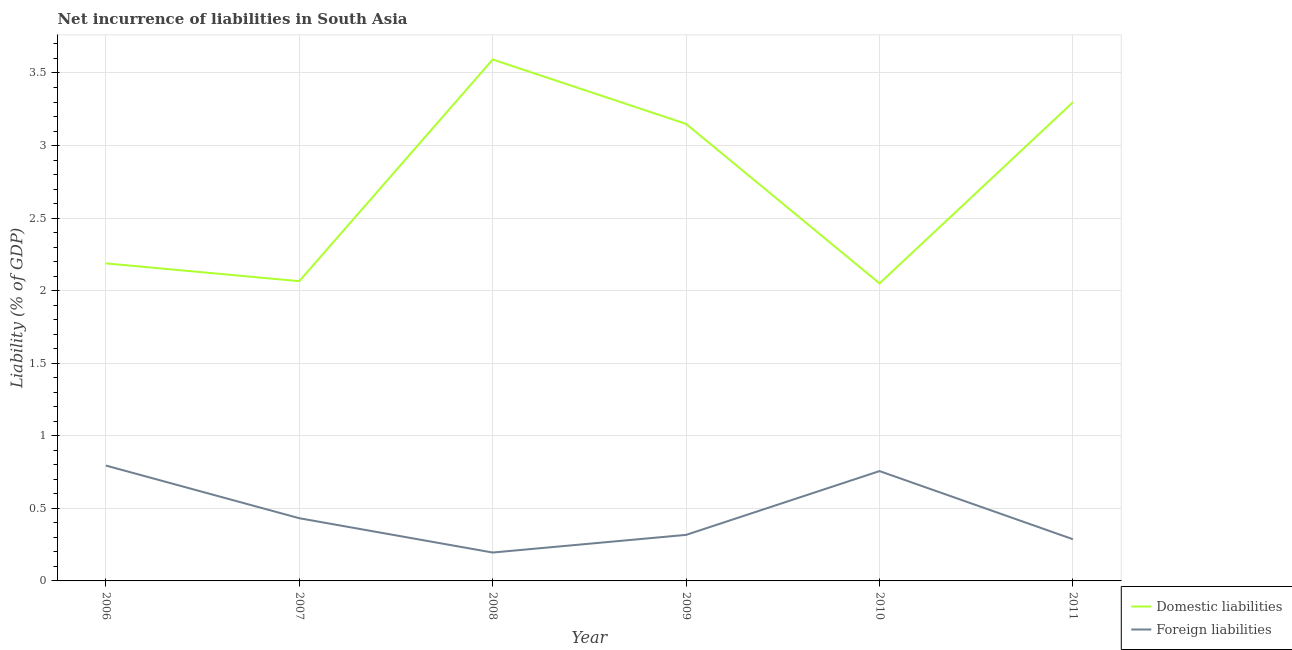How many different coloured lines are there?
Provide a short and direct response. 2. Is the number of lines equal to the number of legend labels?
Your response must be concise. Yes. What is the incurrence of foreign liabilities in 2011?
Provide a succinct answer. 0.29. Across all years, what is the maximum incurrence of domestic liabilities?
Make the answer very short. 3.59. Across all years, what is the minimum incurrence of foreign liabilities?
Your answer should be very brief. 0.2. What is the total incurrence of foreign liabilities in the graph?
Provide a succinct answer. 2.78. What is the difference between the incurrence of domestic liabilities in 2008 and that in 2010?
Provide a short and direct response. 1.54. What is the difference between the incurrence of domestic liabilities in 2011 and the incurrence of foreign liabilities in 2006?
Offer a very short reply. 2.5. What is the average incurrence of foreign liabilities per year?
Offer a terse response. 0.46. In the year 2006, what is the difference between the incurrence of foreign liabilities and incurrence of domestic liabilities?
Your answer should be compact. -1.39. In how many years, is the incurrence of domestic liabilities greater than 2.9 %?
Your answer should be very brief. 3. What is the ratio of the incurrence of foreign liabilities in 2007 to that in 2008?
Your answer should be compact. 2.21. Is the incurrence of foreign liabilities in 2010 less than that in 2011?
Give a very brief answer. No. Is the difference between the incurrence of foreign liabilities in 2010 and 2011 greater than the difference between the incurrence of domestic liabilities in 2010 and 2011?
Keep it short and to the point. Yes. What is the difference between the highest and the second highest incurrence of domestic liabilities?
Your response must be concise. 0.29. What is the difference between the highest and the lowest incurrence of foreign liabilities?
Give a very brief answer. 0.6. In how many years, is the incurrence of domestic liabilities greater than the average incurrence of domestic liabilities taken over all years?
Your answer should be very brief. 3. Is the incurrence of domestic liabilities strictly greater than the incurrence of foreign liabilities over the years?
Make the answer very short. Yes. Is the incurrence of foreign liabilities strictly less than the incurrence of domestic liabilities over the years?
Offer a very short reply. Yes. How many lines are there?
Give a very brief answer. 2. What is the difference between two consecutive major ticks on the Y-axis?
Your answer should be very brief. 0.5. Does the graph contain grids?
Your answer should be compact. Yes. Where does the legend appear in the graph?
Provide a short and direct response. Bottom right. How are the legend labels stacked?
Ensure brevity in your answer.  Vertical. What is the title of the graph?
Provide a short and direct response. Net incurrence of liabilities in South Asia. What is the label or title of the X-axis?
Offer a very short reply. Year. What is the label or title of the Y-axis?
Keep it short and to the point. Liability (% of GDP). What is the Liability (% of GDP) of Domestic liabilities in 2006?
Keep it short and to the point. 2.19. What is the Liability (% of GDP) in Foreign liabilities in 2006?
Provide a short and direct response. 0.8. What is the Liability (% of GDP) in Domestic liabilities in 2007?
Provide a short and direct response. 2.07. What is the Liability (% of GDP) in Foreign liabilities in 2007?
Your response must be concise. 0.43. What is the Liability (% of GDP) in Domestic liabilities in 2008?
Keep it short and to the point. 3.59. What is the Liability (% of GDP) of Foreign liabilities in 2008?
Offer a terse response. 0.2. What is the Liability (% of GDP) of Domestic liabilities in 2009?
Make the answer very short. 3.15. What is the Liability (% of GDP) of Foreign liabilities in 2009?
Offer a very short reply. 0.32. What is the Liability (% of GDP) in Domestic liabilities in 2010?
Ensure brevity in your answer.  2.05. What is the Liability (% of GDP) in Foreign liabilities in 2010?
Your answer should be very brief. 0.76. What is the Liability (% of GDP) in Domestic liabilities in 2011?
Offer a terse response. 3.3. What is the Liability (% of GDP) in Foreign liabilities in 2011?
Keep it short and to the point. 0.29. Across all years, what is the maximum Liability (% of GDP) in Domestic liabilities?
Offer a terse response. 3.59. Across all years, what is the maximum Liability (% of GDP) in Foreign liabilities?
Keep it short and to the point. 0.8. Across all years, what is the minimum Liability (% of GDP) of Domestic liabilities?
Offer a very short reply. 2.05. Across all years, what is the minimum Liability (% of GDP) in Foreign liabilities?
Your answer should be very brief. 0.2. What is the total Liability (% of GDP) of Domestic liabilities in the graph?
Provide a short and direct response. 16.34. What is the total Liability (% of GDP) in Foreign liabilities in the graph?
Offer a very short reply. 2.78. What is the difference between the Liability (% of GDP) of Domestic liabilities in 2006 and that in 2007?
Your response must be concise. 0.12. What is the difference between the Liability (% of GDP) of Foreign liabilities in 2006 and that in 2007?
Make the answer very short. 0.36. What is the difference between the Liability (% of GDP) of Domestic liabilities in 2006 and that in 2008?
Your response must be concise. -1.4. What is the difference between the Liability (% of GDP) in Foreign liabilities in 2006 and that in 2008?
Offer a terse response. 0.6. What is the difference between the Liability (% of GDP) in Domestic liabilities in 2006 and that in 2009?
Your answer should be very brief. -0.96. What is the difference between the Liability (% of GDP) of Foreign liabilities in 2006 and that in 2009?
Your answer should be very brief. 0.48. What is the difference between the Liability (% of GDP) of Domestic liabilities in 2006 and that in 2010?
Keep it short and to the point. 0.14. What is the difference between the Liability (% of GDP) in Foreign liabilities in 2006 and that in 2010?
Make the answer very short. 0.04. What is the difference between the Liability (% of GDP) of Domestic liabilities in 2006 and that in 2011?
Provide a short and direct response. -1.11. What is the difference between the Liability (% of GDP) in Foreign liabilities in 2006 and that in 2011?
Provide a short and direct response. 0.51. What is the difference between the Liability (% of GDP) of Domestic liabilities in 2007 and that in 2008?
Provide a succinct answer. -1.53. What is the difference between the Liability (% of GDP) in Foreign liabilities in 2007 and that in 2008?
Ensure brevity in your answer.  0.24. What is the difference between the Liability (% of GDP) of Domestic liabilities in 2007 and that in 2009?
Keep it short and to the point. -1.08. What is the difference between the Liability (% of GDP) in Foreign liabilities in 2007 and that in 2009?
Provide a succinct answer. 0.11. What is the difference between the Liability (% of GDP) of Domestic liabilities in 2007 and that in 2010?
Your response must be concise. 0.02. What is the difference between the Liability (% of GDP) in Foreign liabilities in 2007 and that in 2010?
Provide a succinct answer. -0.32. What is the difference between the Liability (% of GDP) in Domestic liabilities in 2007 and that in 2011?
Make the answer very short. -1.23. What is the difference between the Liability (% of GDP) in Foreign liabilities in 2007 and that in 2011?
Offer a very short reply. 0.14. What is the difference between the Liability (% of GDP) of Domestic liabilities in 2008 and that in 2009?
Provide a succinct answer. 0.44. What is the difference between the Liability (% of GDP) of Foreign liabilities in 2008 and that in 2009?
Offer a very short reply. -0.12. What is the difference between the Liability (% of GDP) in Domestic liabilities in 2008 and that in 2010?
Ensure brevity in your answer.  1.54. What is the difference between the Liability (% of GDP) in Foreign liabilities in 2008 and that in 2010?
Offer a terse response. -0.56. What is the difference between the Liability (% of GDP) in Domestic liabilities in 2008 and that in 2011?
Your response must be concise. 0.29. What is the difference between the Liability (% of GDP) in Foreign liabilities in 2008 and that in 2011?
Make the answer very short. -0.09. What is the difference between the Liability (% of GDP) of Domestic liabilities in 2009 and that in 2010?
Keep it short and to the point. 1.1. What is the difference between the Liability (% of GDP) in Foreign liabilities in 2009 and that in 2010?
Give a very brief answer. -0.44. What is the difference between the Liability (% of GDP) in Domestic liabilities in 2009 and that in 2011?
Provide a succinct answer. -0.15. What is the difference between the Liability (% of GDP) of Foreign liabilities in 2009 and that in 2011?
Offer a terse response. 0.03. What is the difference between the Liability (% of GDP) in Domestic liabilities in 2010 and that in 2011?
Ensure brevity in your answer.  -1.25. What is the difference between the Liability (% of GDP) in Foreign liabilities in 2010 and that in 2011?
Give a very brief answer. 0.47. What is the difference between the Liability (% of GDP) in Domestic liabilities in 2006 and the Liability (% of GDP) in Foreign liabilities in 2007?
Ensure brevity in your answer.  1.76. What is the difference between the Liability (% of GDP) of Domestic liabilities in 2006 and the Liability (% of GDP) of Foreign liabilities in 2008?
Keep it short and to the point. 1.99. What is the difference between the Liability (% of GDP) of Domestic liabilities in 2006 and the Liability (% of GDP) of Foreign liabilities in 2009?
Ensure brevity in your answer.  1.87. What is the difference between the Liability (% of GDP) of Domestic liabilities in 2006 and the Liability (% of GDP) of Foreign liabilities in 2010?
Offer a very short reply. 1.43. What is the difference between the Liability (% of GDP) of Domestic liabilities in 2006 and the Liability (% of GDP) of Foreign liabilities in 2011?
Give a very brief answer. 1.9. What is the difference between the Liability (% of GDP) of Domestic liabilities in 2007 and the Liability (% of GDP) of Foreign liabilities in 2008?
Keep it short and to the point. 1.87. What is the difference between the Liability (% of GDP) of Domestic liabilities in 2007 and the Liability (% of GDP) of Foreign liabilities in 2009?
Your answer should be very brief. 1.75. What is the difference between the Liability (% of GDP) of Domestic liabilities in 2007 and the Liability (% of GDP) of Foreign liabilities in 2010?
Your answer should be very brief. 1.31. What is the difference between the Liability (% of GDP) in Domestic liabilities in 2007 and the Liability (% of GDP) in Foreign liabilities in 2011?
Provide a succinct answer. 1.78. What is the difference between the Liability (% of GDP) in Domestic liabilities in 2008 and the Liability (% of GDP) in Foreign liabilities in 2009?
Provide a short and direct response. 3.28. What is the difference between the Liability (% of GDP) of Domestic liabilities in 2008 and the Liability (% of GDP) of Foreign liabilities in 2010?
Your response must be concise. 2.84. What is the difference between the Liability (% of GDP) in Domestic liabilities in 2008 and the Liability (% of GDP) in Foreign liabilities in 2011?
Your response must be concise. 3.31. What is the difference between the Liability (% of GDP) in Domestic liabilities in 2009 and the Liability (% of GDP) in Foreign liabilities in 2010?
Your response must be concise. 2.39. What is the difference between the Liability (% of GDP) in Domestic liabilities in 2009 and the Liability (% of GDP) in Foreign liabilities in 2011?
Your answer should be very brief. 2.86. What is the difference between the Liability (% of GDP) in Domestic liabilities in 2010 and the Liability (% of GDP) in Foreign liabilities in 2011?
Give a very brief answer. 1.76. What is the average Liability (% of GDP) of Domestic liabilities per year?
Offer a very short reply. 2.72. What is the average Liability (% of GDP) of Foreign liabilities per year?
Provide a succinct answer. 0.46. In the year 2006, what is the difference between the Liability (% of GDP) in Domestic liabilities and Liability (% of GDP) in Foreign liabilities?
Ensure brevity in your answer.  1.39. In the year 2007, what is the difference between the Liability (% of GDP) in Domestic liabilities and Liability (% of GDP) in Foreign liabilities?
Your answer should be very brief. 1.63. In the year 2008, what is the difference between the Liability (% of GDP) in Domestic liabilities and Liability (% of GDP) in Foreign liabilities?
Your response must be concise. 3.4. In the year 2009, what is the difference between the Liability (% of GDP) of Domestic liabilities and Liability (% of GDP) of Foreign liabilities?
Provide a succinct answer. 2.83. In the year 2010, what is the difference between the Liability (% of GDP) of Domestic liabilities and Liability (% of GDP) of Foreign liabilities?
Offer a very short reply. 1.29. In the year 2011, what is the difference between the Liability (% of GDP) in Domestic liabilities and Liability (% of GDP) in Foreign liabilities?
Provide a succinct answer. 3.01. What is the ratio of the Liability (% of GDP) of Domestic liabilities in 2006 to that in 2007?
Ensure brevity in your answer.  1.06. What is the ratio of the Liability (% of GDP) of Foreign liabilities in 2006 to that in 2007?
Offer a terse response. 1.84. What is the ratio of the Liability (% of GDP) of Domestic liabilities in 2006 to that in 2008?
Your answer should be compact. 0.61. What is the ratio of the Liability (% of GDP) in Foreign liabilities in 2006 to that in 2008?
Ensure brevity in your answer.  4.06. What is the ratio of the Liability (% of GDP) of Domestic liabilities in 2006 to that in 2009?
Keep it short and to the point. 0.69. What is the ratio of the Liability (% of GDP) of Foreign liabilities in 2006 to that in 2009?
Your answer should be very brief. 2.51. What is the ratio of the Liability (% of GDP) in Domestic liabilities in 2006 to that in 2010?
Your answer should be compact. 1.07. What is the ratio of the Liability (% of GDP) of Foreign liabilities in 2006 to that in 2010?
Provide a succinct answer. 1.05. What is the ratio of the Liability (% of GDP) in Domestic liabilities in 2006 to that in 2011?
Provide a short and direct response. 0.66. What is the ratio of the Liability (% of GDP) of Foreign liabilities in 2006 to that in 2011?
Your answer should be compact. 2.77. What is the ratio of the Liability (% of GDP) of Domestic liabilities in 2007 to that in 2008?
Your answer should be very brief. 0.57. What is the ratio of the Liability (% of GDP) in Foreign liabilities in 2007 to that in 2008?
Your response must be concise. 2.21. What is the ratio of the Liability (% of GDP) of Domestic liabilities in 2007 to that in 2009?
Ensure brevity in your answer.  0.66. What is the ratio of the Liability (% of GDP) in Foreign liabilities in 2007 to that in 2009?
Provide a succinct answer. 1.36. What is the ratio of the Liability (% of GDP) of Domestic liabilities in 2007 to that in 2010?
Offer a very short reply. 1.01. What is the ratio of the Liability (% of GDP) in Foreign liabilities in 2007 to that in 2010?
Offer a very short reply. 0.57. What is the ratio of the Liability (% of GDP) of Domestic liabilities in 2007 to that in 2011?
Your response must be concise. 0.63. What is the ratio of the Liability (% of GDP) in Foreign liabilities in 2007 to that in 2011?
Make the answer very short. 1.5. What is the ratio of the Liability (% of GDP) of Domestic liabilities in 2008 to that in 2009?
Ensure brevity in your answer.  1.14. What is the ratio of the Liability (% of GDP) in Foreign liabilities in 2008 to that in 2009?
Make the answer very short. 0.62. What is the ratio of the Liability (% of GDP) of Domestic liabilities in 2008 to that in 2010?
Make the answer very short. 1.75. What is the ratio of the Liability (% of GDP) of Foreign liabilities in 2008 to that in 2010?
Your answer should be very brief. 0.26. What is the ratio of the Liability (% of GDP) of Domestic liabilities in 2008 to that in 2011?
Your answer should be very brief. 1.09. What is the ratio of the Liability (% of GDP) of Foreign liabilities in 2008 to that in 2011?
Provide a succinct answer. 0.68. What is the ratio of the Liability (% of GDP) of Domestic liabilities in 2009 to that in 2010?
Your response must be concise. 1.54. What is the ratio of the Liability (% of GDP) of Foreign liabilities in 2009 to that in 2010?
Your response must be concise. 0.42. What is the ratio of the Liability (% of GDP) in Domestic liabilities in 2009 to that in 2011?
Your response must be concise. 0.95. What is the ratio of the Liability (% of GDP) in Foreign liabilities in 2009 to that in 2011?
Give a very brief answer. 1.1. What is the ratio of the Liability (% of GDP) in Domestic liabilities in 2010 to that in 2011?
Give a very brief answer. 0.62. What is the ratio of the Liability (% of GDP) of Foreign liabilities in 2010 to that in 2011?
Offer a very short reply. 2.63. What is the difference between the highest and the second highest Liability (% of GDP) in Domestic liabilities?
Offer a terse response. 0.29. What is the difference between the highest and the second highest Liability (% of GDP) of Foreign liabilities?
Keep it short and to the point. 0.04. What is the difference between the highest and the lowest Liability (% of GDP) of Domestic liabilities?
Offer a very short reply. 1.54. What is the difference between the highest and the lowest Liability (% of GDP) of Foreign liabilities?
Offer a terse response. 0.6. 